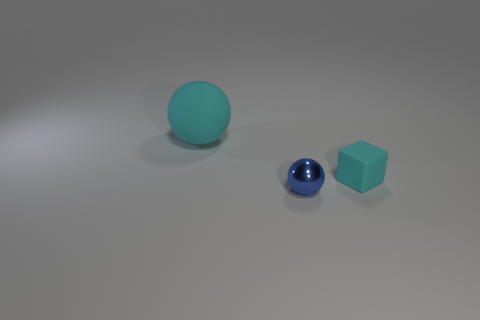What size is the rubber ball that is the same color as the cube?
Make the answer very short. Large. What shape is the large thing that is the same color as the small rubber object?
Your response must be concise. Sphere. Is the number of green rubber things less than the number of tiny blue objects?
Provide a short and direct response. Yes. Is there anything else that is the same color as the small cube?
Give a very brief answer. Yes. What is the shape of the tiny object that is to the left of the tiny cyan object?
Offer a terse response. Sphere. There is a big ball; is it the same color as the sphere that is to the right of the large sphere?
Make the answer very short. No. Is the number of shiny spheres that are behind the large cyan rubber sphere the same as the number of small rubber cubes behind the cyan rubber block?
Your response must be concise. Yes. What number of other objects are the same size as the cyan rubber sphere?
Your answer should be compact. 0. What is the size of the cyan matte ball?
Your response must be concise. Large. Is the small sphere made of the same material as the sphere that is behind the small cyan thing?
Your response must be concise. No. 